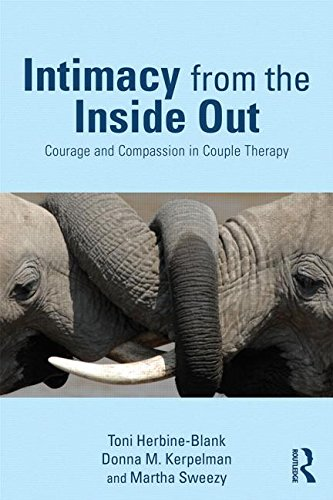Can you discuss the significance of the elephant imagery on this book cover? The elephant imagery on the cover likely symbolizes deep connections and memory, attributes relevant to couples undergoing therapy to remember and strengthen their bonds. 